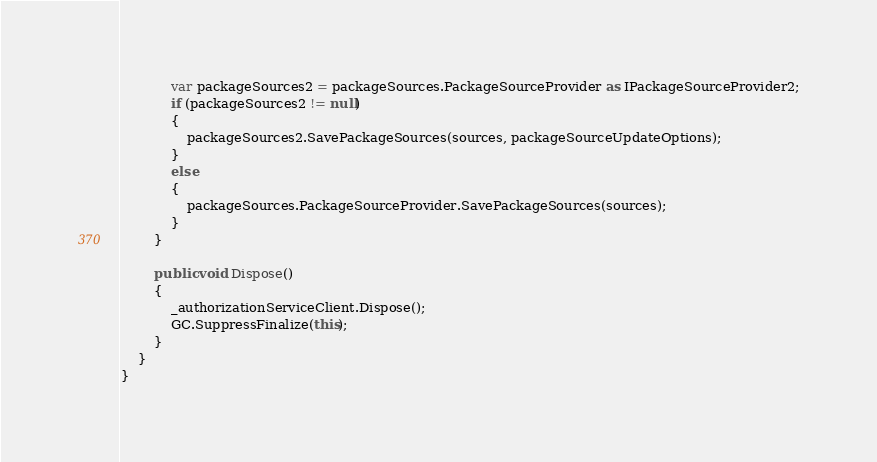Convert code to text. <code><loc_0><loc_0><loc_500><loc_500><_C#_>            var packageSources2 = packageSources.PackageSourceProvider as IPackageSourceProvider2;
            if (packageSources2 != null)
            {
                packageSources2.SavePackageSources(sources, packageSourceUpdateOptions);
            }
            else
            {
                packageSources.PackageSourceProvider.SavePackageSources(sources);
            }
        }

        public void Dispose()
        {
            _authorizationServiceClient.Dispose();
            GC.SuppressFinalize(this);
        }
    }
}
</code> 